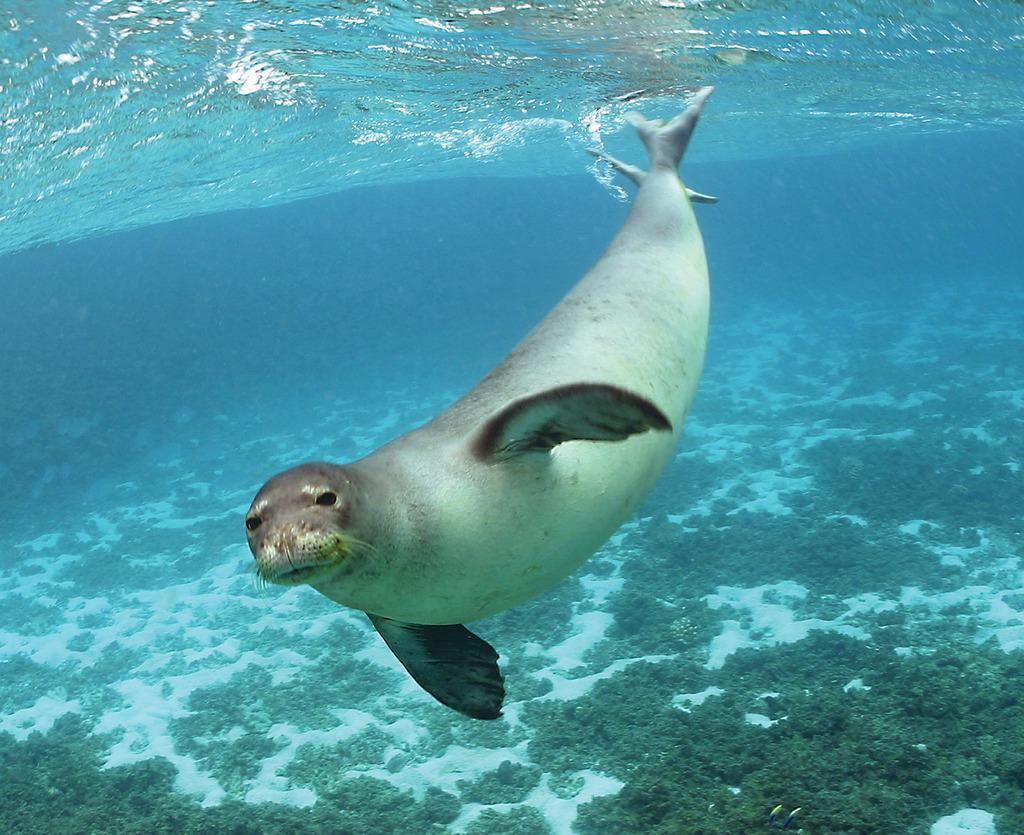What is the primary element in the image? There is water in the image. What type of animal can be seen in the water? A seal is visible in the water. What can be found at the bottom of the image? There are underwater plants at the bottom of the image. What type of power source is visible in the image? There is no power source visible in the image; it features water, a seal, and underwater plants. Can you see a ship in the image? There is no ship present in the image. 